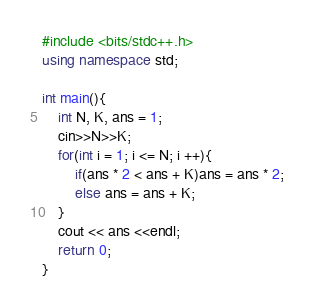Convert code to text. <code><loc_0><loc_0><loc_500><loc_500><_C++_>#include <bits/stdc++.h>
using namespace std;

int main(){
	int N, K, ans = 1;
	cin>>N>>K;
	for(int i = 1; i <= N; i ++){
		if(ans * 2 < ans + K)ans = ans * 2;
		else ans = ans + K;
	}
	cout << ans <<endl;
	return 0;
}</code> 